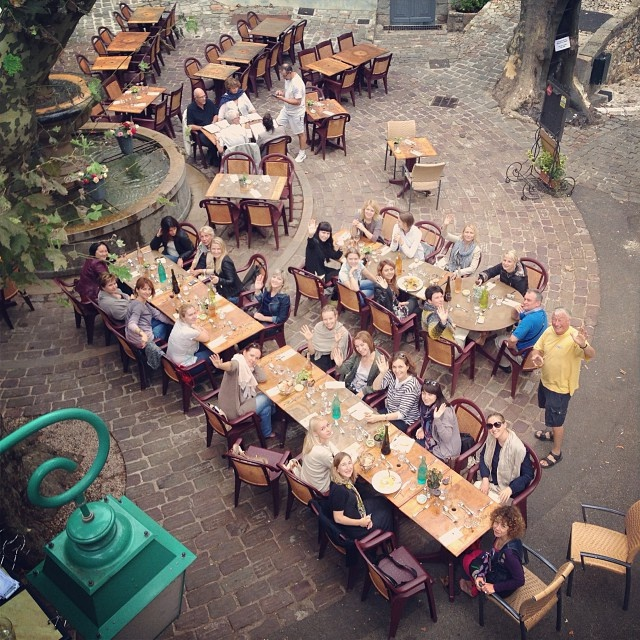Describe the objects in this image and their specific colors. I can see chair in black, gray, and maroon tones, people in black, tan, lightgray, and darkgray tones, dining table in black, tan, and ivory tones, dining table in black, tan, and ivory tones, and dining table in black, tan, and lightgray tones in this image. 